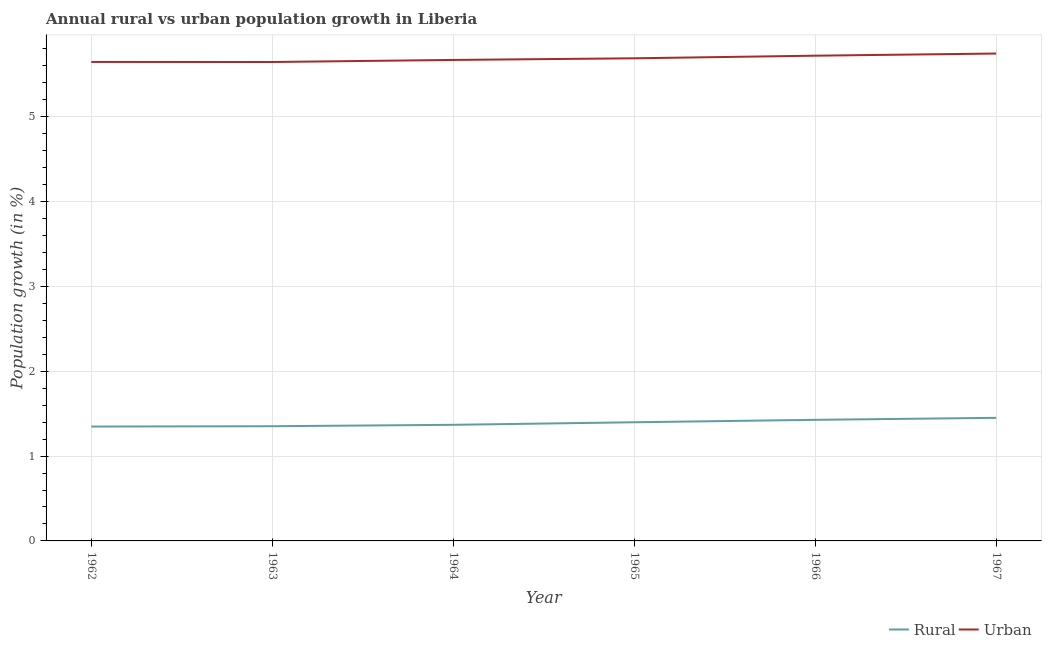Does the line corresponding to rural population growth intersect with the line corresponding to urban population growth?
Offer a terse response. No. Is the number of lines equal to the number of legend labels?
Make the answer very short. Yes. What is the rural population growth in 1965?
Your answer should be very brief. 1.4. Across all years, what is the maximum rural population growth?
Ensure brevity in your answer.  1.45. Across all years, what is the minimum urban population growth?
Offer a very short reply. 5.65. In which year was the urban population growth maximum?
Offer a terse response. 1967. In which year was the urban population growth minimum?
Your answer should be compact. 1963. What is the total rural population growth in the graph?
Keep it short and to the point. 8.35. What is the difference between the rural population growth in 1963 and that in 1967?
Keep it short and to the point. -0.1. What is the difference between the urban population growth in 1967 and the rural population growth in 1965?
Give a very brief answer. 4.35. What is the average rural population growth per year?
Your answer should be very brief. 1.39. In the year 1964, what is the difference between the rural population growth and urban population growth?
Ensure brevity in your answer.  -4.3. In how many years, is the urban population growth greater than 0.8 %?
Offer a very short reply. 6. What is the ratio of the rural population growth in 1963 to that in 1965?
Provide a succinct answer. 0.97. Is the difference between the urban population growth in 1962 and 1966 greater than the difference between the rural population growth in 1962 and 1966?
Offer a terse response. Yes. What is the difference between the highest and the second highest rural population growth?
Make the answer very short. 0.02. What is the difference between the highest and the lowest rural population growth?
Provide a short and direct response. 0.1. Is the urban population growth strictly greater than the rural population growth over the years?
Give a very brief answer. Yes. How many years are there in the graph?
Make the answer very short. 6. What is the difference between two consecutive major ticks on the Y-axis?
Give a very brief answer. 1. Does the graph contain any zero values?
Offer a terse response. No. Does the graph contain grids?
Ensure brevity in your answer.  Yes. How many legend labels are there?
Keep it short and to the point. 2. How are the legend labels stacked?
Provide a short and direct response. Horizontal. What is the title of the graph?
Offer a very short reply. Annual rural vs urban population growth in Liberia. Does "Forest" appear as one of the legend labels in the graph?
Ensure brevity in your answer.  No. What is the label or title of the X-axis?
Your response must be concise. Year. What is the label or title of the Y-axis?
Offer a very short reply. Population growth (in %). What is the Population growth (in %) in Rural in 1962?
Give a very brief answer. 1.35. What is the Population growth (in %) of Urban  in 1962?
Your answer should be compact. 5.65. What is the Population growth (in %) in Rural in 1963?
Offer a terse response. 1.35. What is the Population growth (in %) in Urban  in 1963?
Make the answer very short. 5.65. What is the Population growth (in %) in Rural in 1964?
Offer a very short reply. 1.37. What is the Population growth (in %) of Urban  in 1964?
Your answer should be compact. 5.67. What is the Population growth (in %) of Rural in 1965?
Offer a very short reply. 1.4. What is the Population growth (in %) in Urban  in 1965?
Provide a succinct answer. 5.69. What is the Population growth (in %) of Rural in 1966?
Keep it short and to the point. 1.43. What is the Population growth (in %) in Urban  in 1966?
Make the answer very short. 5.72. What is the Population growth (in %) of Rural in 1967?
Give a very brief answer. 1.45. What is the Population growth (in %) in Urban  in 1967?
Your answer should be compact. 5.75. Across all years, what is the maximum Population growth (in %) in Rural?
Give a very brief answer. 1.45. Across all years, what is the maximum Population growth (in %) of Urban ?
Provide a short and direct response. 5.75. Across all years, what is the minimum Population growth (in %) in Rural?
Keep it short and to the point. 1.35. Across all years, what is the minimum Population growth (in %) in Urban ?
Your answer should be very brief. 5.65. What is the total Population growth (in %) of Rural in the graph?
Keep it short and to the point. 8.35. What is the total Population growth (in %) in Urban  in the graph?
Make the answer very short. 34.12. What is the difference between the Population growth (in %) in Rural in 1962 and that in 1963?
Provide a succinct answer. -0. What is the difference between the Population growth (in %) of Urban  in 1962 and that in 1963?
Keep it short and to the point. 0. What is the difference between the Population growth (in %) in Rural in 1962 and that in 1964?
Offer a terse response. -0.02. What is the difference between the Population growth (in %) of Urban  in 1962 and that in 1964?
Your response must be concise. -0.02. What is the difference between the Population growth (in %) of Rural in 1962 and that in 1965?
Offer a terse response. -0.05. What is the difference between the Population growth (in %) of Urban  in 1962 and that in 1965?
Give a very brief answer. -0.04. What is the difference between the Population growth (in %) in Rural in 1962 and that in 1966?
Provide a short and direct response. -0.08. What is the difference between the Population growth (in %) in Urban  in 1962 and that in 1966?
Make the answer very short. -0.07. What is the difference between the Population growth (in %) of Rural in 1962 and that in 1967?
Give a very brief answer. -0.1. What is the difference between the Population growth (in %) of Urban  in 1962 and that in 1967?
Your response must be concise. -0.1. What is the difference between the Population growth (in %) in Rural in 1963 and that in 1964?
Offer a very short reply. -0.02. What is the difference between the Population growth (in %) of Urban  in 1963 and that in 1964?
Your answer should be very brief. -0.02. What is the difference between the Population growth (in %) in Rural in 1963 and that in 1965?
Offer a terse response. -0.05. What is the difference between the Population growth (in %) in Urban  in 1963 and that in 1965?
Ensure brevity in your answer.  -0.04. What is the difference between the Population growth (in %) of Rural in 1963 and that in 1966?
Make the answer very short. -0.08. What is the difference between the Population growth (in %) in Urban  in 1963 and that in 1966?
Make the answer very short. -0.07. What is the difference between the Population growth (in %) of Rural in 1963 and that in 1967?
Your answer should be very brief. -0.1. What is the difference between the Population growth (in %) of Rural in 1964 and that in 1965?
Give a very brief answer. -0.03. What is the difference between the Population growth (in %) in Urban  in 1964 and that in 1965?
Your answer should be very brief. -0.02. What is the difference between the Population growth (in %) in Rural in 1964 and that in 1966?
Offer a very short reply. -0.06. What is the difference between the Population growth (in %) in Urban  in 1964 and that in 1966?
Provide a succinct answer. -0.05. What is the difference between the Population growth (in %) in Rural in 1964 and that in 1967?
Your answer should be compact. -0.08. What is the difference between the Population growth (in %) of Urban  in 1964 and that in 1967?
Your response must be concise. -0.08. What is the difference between the Population growth (in %) in Rural in 1965 and that in 1966?
Keep it short and to the point. -0.03. What is the difference between the Population growth (in %) in Urban  in 1965 and that in 1966?
Your answer should be compact. -0.03. What is the difference between the Population growth (in %) in Rural in 1965 and that in 1967?
Offer a terse response. -0.05. What is the difference between the Population growth (in %) of Urban  in 1965 and that in 1967?
Your answer should be compact. -0.06. What is the difference between the Population growth (in %) in Rural in 1966 and that in 1967?
Provide a succinct answer. -0.02. What is the difference between the Population growth (in %) of Urban  in 1966 and that in 1967?
Offer a very short reply. -0.03. What is the difference between the Population growth (in %) in Rural in 1962 and the Population growth (in %) in Urban  in 1963?
Your answer should be compact. -4.3. What is the difference between the Population growth (in %) of Rural in 1962 and the Population growth (in %) of Urban  in 1964?
Offer a very short reply. -4.32. What is the difference between the Population growth (in %) of Rural in 1962 and the Population growth (in %) of Urban  in 1965?
Offer a very short reply. -4.34. What is the difference between the Population growth (in %) of Rural in 1962 and the Population growth (in %) of Urban  in 1966?
Offer a very short reply. -4.37. What is the difference between the Population growth (in %) of Rural in 1962 and the Population growth (in %) of Urban  in 1967?
Give a very brief answer. -4.4. What is the difference between the Population growth (in %) in Rural in 1963 and the Population growth (in %) in Urban  in 1964?
Provide a short and direct response. -4.32. What is the difference between the Population growth (in %) of Rural in 1963 and the Population growth (in %) of Urban  in 1965?
Keep it short and to the point. -4.34. What is the difference between the Population growth (in %) of Rural in 1963 and the Population growth (in %) of Urban  in 1966?
Provide a short and direct response. -4.37. What is the difference between the Population growth (in %) of Rural in 1963 and the Population growth (in %) of Urban  in 1967?
Your response must be concise. -4.39. What is the difference between the Population growth (in %) in Rural in 1964 and the Population growth (in %) in Urban  in 1965?
Your answer should be very brief. -4.32. What is the difference between the Population growth (in %) of Rural in 1964 and the Population growth (in %) of Urban  in 1966?
Your answer should be compact. -4.35. What is the difference between the Population growth (in %) in Rural in 1964 and the Population growth (in %) in Urban  in 1967?
Provide a short and direct response. -4.38. What is the difference between the Population growth (in %) in Rural in 1965 and the Population growth (in %) in Urban  in 1966?
Keep it short and to the point. -4.32. What is the difference between the Population growth (in %) of Rural in 1965 and the Population growth (in %) of Urban  in 1967?
Provide a short and direct response. -4.35. What is the difference between the Population growth (in %) in Rural in 1966 and the Population growth (in %) in Urban  in 1967?
Your response must be concise. -4.32. What is the average Population growth (in %) of Rural per year?
Ensure brevity in your answer.  1.39. What is the average Population growth (in %) in Urban  per year?
Give a very brief answer. 5.69. In the year 1962, what is the difference between the Population growth (in %) of Rural and Population growth (in %) of Urban ?
Offer a terse response. -4.3. In the year 1963, what is the difference between the Population growth (in %) of Rural and Population growth (in %) of Urban ?
Provide a short and direct response. -4.29. In the year 1964, what is the difference between the Population growth (in %) of Rural and Population growth (in %) of Urban ?
Offer a terse response. -4.3. In the year 1965, what is the difference between the Population growth (in %) in Rural and Population growth (in %) in Urban ?
Give a very brief answer. -4.29. In the year 1966, what is the difference between the Population growth (in %) of Rural and Population growth (in %) of Urban ?
Give a very brief answer. -4.29. In the year 1967, what is the difference between the Population growth (in %) in Rural and Population growth (in %) in Urban ?
Keep it short and to the point. -4.29. What is the ratio of the Population growth (in %) of Rural in 1962 to that in 1963?
Your response must be concise. 1. What is the ratio of the Population growth (in %) of Rural in 1962 to that in 1964?
Your answer should be very brief. 0.99. What is the ratio of the Population growth (in %) in Urban  in 1962 to that in 1964?
Make the answer very short. 1. What is the ratio of the Population growth (in %) in Rural in 1962 to that in 1965?
Your answer should be very brief. 0.96. What is the ratio of the Population growth (in %) in Urban  in 1962 to that in 1965?
Provide a succinct answer. 0.99. What is the ratio of the Population growth (in %) of Rural in 1962 to that in 1966?
Your response must be concise. 0.94. What is the ratio of the Population growth (in %) in Urban  in 1962 to that in 1966?
Offer a terse response. 0.99. What is the ratio of the Population growth (in %) in Rural in 1962 to that in 1967?
Your response must be concise. 0.93. What is the ratio of the Population growth (in %) of Urban  in 1962 to that in 1967?
Offer a very short reply. 0.98. What is the ratio of the Population growth (in %) in Rural in 1963 to that in 1964?
Your answer should be very brief. 0.99. What is the ratio of the Population growth (in %) in Rural in 1963 to that in 1965?
Give a very brief answer. 0.97. What is the ratio of the Population growth (in %) in Urban  in 1963 to that in 1965?
Give a very brief answer. 0.99. What is the ratio of the Population growth (in %) of Rural in 1963 to that in 1966?
Your answer should be very brief. 0.95. What is the ratio of the Population growth (in %) in Urban  in 1963 to that in 1966?
Your answer should be very brief. 0.99. What is the ratio of the Population growth (in %) in Rural in 1963 to that in 1967?
Provide a short and direct response. 0.93. What is the ratio of the Population growth (in %) of Urban  in 1963 to that in 1967?
Offer a terse response. 0.98. What is the ratio of the Population growth (in %) in Rural in 1964 to that in 1965?
Give a very brief answer. 0.98. What is the ratio of the Population growth (in %) in Urban  in 1964 to that in 1965?
Your answer should be compact. 1. What is the ratio of the Population growth (in %) in Rural in 1964 to that in 1966?
Your answer should be compact. 0.96. What is the ratio of the Population growth (in %) of Urban  in 1964 to that in 1966?
Provide a short and direct response. 0.99. What is the ratio of the Population growth (in %) in Rural in 1964 to that in 1967?
Offer a terse response. 0.94. What is the ratio of the Population growth (in %) in Urban  in 1964 to that in 1967?
Provide a short and direct response. 0.99. What is the ratio of the Population growth (in %) in Rural in 1965 to that in 1966?
Your answer should be very brief. 0.98. What is the ratio of the Population growth (in %) in Urban  in 1965 to that in 1966?
Keep it short and to the point. 0.99. What is the ratio of the Population growth (in %) of Rural in 1965 to that in 1967?
Your answer should be compact. 0.96. What is the ratio of the Population growth (in %) of Urban  in 1965 to that in 1967?
Offer a terse response. 0.99. What is the ratio of the Population growth (in %) of Rural in 1966 to that in 1967?
Provide a succinct answer. 0.98. What is the difference between the highest and the second highest Population growth (in %) in Rural?
Keep it short and to the point. 0.02. What is the difference between the highest and the second highest Population growth (in %) in Urban ?
Offer a very short reply. 0.03. What is the difference between the highest and the lowest Population growth (in %) of Rural?
Offer a terse response. 0.1. What is the difference between the highest and the lowest Population growth (in %) in Urban ?
Your response must be concise. 0.1. 